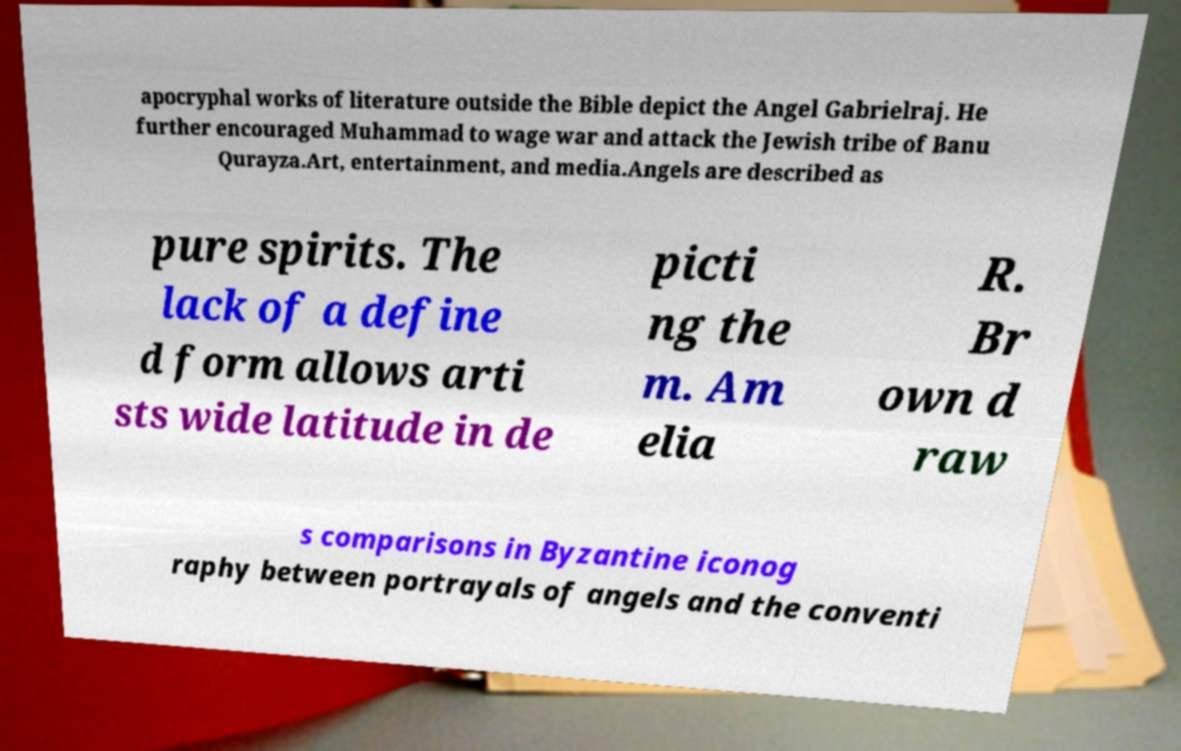Please identify and transcribe the text found in this image. apocryphal works of literature outside the Bible depict the Angel Gabrielraj. He further encouraged Muhammad to wage war and attack the Jewish tribe of Banu Qurayza.Art, entertainment, and media.Angels are described as pure spirits. The lack of a define d form allows arti sts wide latitude in de picti ng the m. Am elia R. Br own d raw s comparisons in Byzantine iconog raphy between portrayals of angels and the conventi 